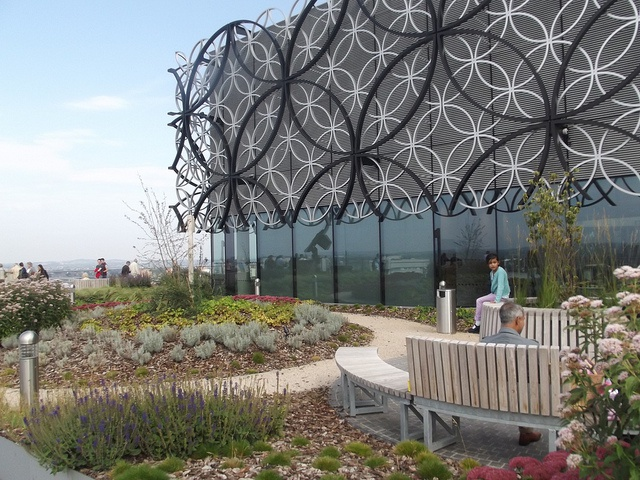Describe the objects in this image and their specific colors. I can see bench in lightblue, darkgray, and gray tones, bench in lightblue, gray, lightgray, darkgray, and black tones, people in lightblue, darkgray, black, teal, and gray tones, people in lightblue, gray, and darkgray tones, and people in lightblue, gray, darkgray, black, and lightgray tones in this image. 